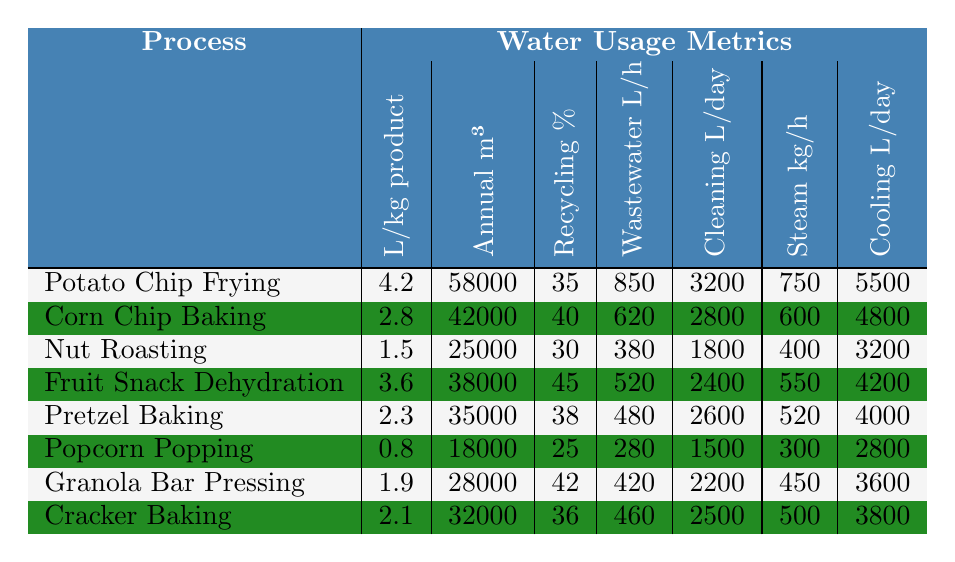What is the water usage per kilogram of product for popcorn? The table indicates that the water usage for popcorn is listed in the "Liters per kg product" column, where Popcorn Popping shows a value of 0.8.
Answer: 0.8 Which snack production process has the highest annual water consumption? By examining the "Annual water consumption (m³)" column, Potato Chip Frying has the highest value at 58000 m³.
Answer: Potato Chip Frying What is the water recycling rate for nut roasting? The water recycling rate for Nut Roasting is found in the corresponding column, which shows a value of 30%.
Answer: 30% How does the cooling tower evaporation for cracker baking compare to that of corn chip baking? The cooling tower evaporation for Cracker Baking is 3800 L/day, while for Corn Chip Baking it is 4800 L/day. The difference indicates that Corn Chip Baking uses more water for cooling tower evaporation than Cracker Baking.
Answer: Cracker Baking uses 1000 L/day less What is the average cleaning water usage for all the snack production processes listed? To find the average, sum the daily cleaning water usage values (3200 + 2800 + 1800 + 2400 + 2600 + 1500 + 2200 + 2500 = 18600) and divide by the number of processes (8), resulting in an average of 2325 L/day.
Answer: 2325 Is the wastewater generated from popcorn production less than that from fruit snack dehydration? Wastewater generated for Popcorn Popping is 280 L/hour, while for Fruit Snack Dehydration it is 520 L/hour. Since 280 is less than 520, the statement is true.
Answer: Yes Which process has the lowest liters of water used per kilogram of product? Examining the "Liters per kg product" column, Popcorn Popping has the lowest value at 0.8 liters per kg.
Answer: Popcorn Popping If we consider the water recycling rates for all processes, which one has the highest percentage? The water recycling rates show that Fruit Snack Dehydration has the highest percentage at 45%.
Answer: 45% What is the total annual water consumption of the two processes that use the least water per kilogram of product? The lowest water usage per kg is Popcorn Popping (18000 m³) and Nut Roasting (25000 m³). Adding these values yields a total of 43000 m³.
Answer: 43000 m³ How much more cleaning water is used daily in potato chip frying compared to nut roasting? The cleaning water usage for Potato Chip Frying is 3200 L/day and for Nut Roasting is 1800 L/day. The difference is 3200 - 1800 = 1400 L/day.
Answer: 1400 L/day Is the steam generation (kg/hour) for granola bar pressing greater than that of pretzel baking? Granola Bar Pressing has a steam generation rate of 450 kg/hour, while Pretzel Baking has 520 kg/hour. Since 450 is less than 520, the answer is no.
Answer: No 